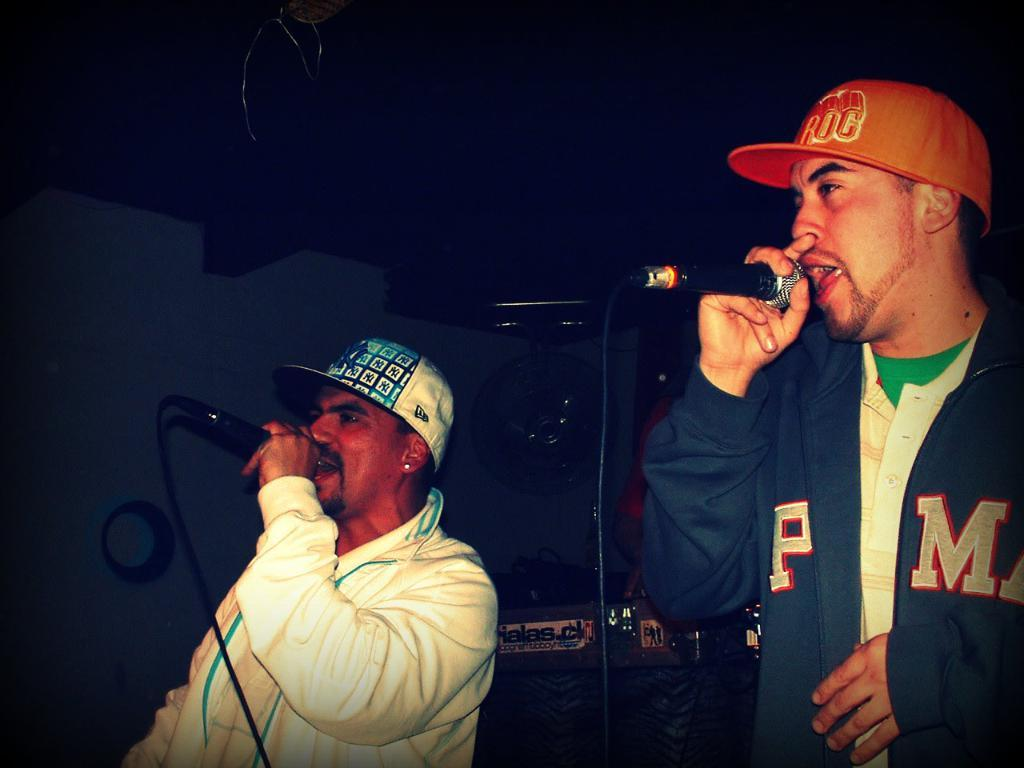How many people are in the image? There are two men in the image. What are the men doing in the image? Both men are singing into microphones. Can you describe any objects in the background of the image? There is a speaker visible in the background. What type of cork can be seen on the basketball court in the image? There is no basketball court or cork present in the image. How many beans are visible on the men's clothing in the image? There are no beans visible on the men's clothing in the image. 